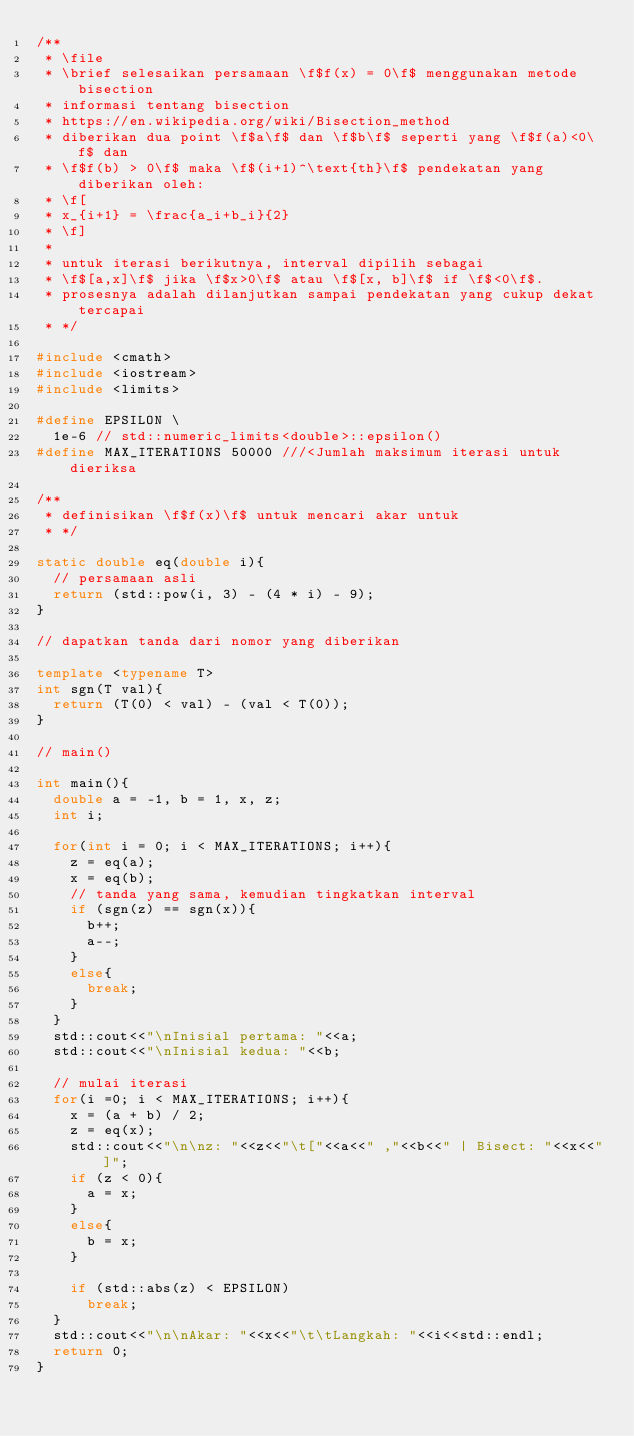Convert code to text. <code><loc_0><loc_0><loc_500><loc_500><_C++_>/**
 * \file
 * \brief selesaikan persamaan \f$f(x) = 0\f$ menggunakan metode bisection
 * informasi tentang bisection
 * https://en.wikipedia.org/wiki/Bisection_method
 * diberikan dua point \f$a\f$ dan \f$b\f$ seperti yang \f$f(a)<0\f$ dan
 * \f$f(b) > 0\f$ maka \f$(i+1)^\text{th}\f$ pendekatan yang diberikan oleh:
 * \f[
 * x_{i+1} = \frac{a_i+b_i}{2}
 * \f]
 *
 * untuk iterasi berikutnya, interval dipilih sebagai
 * \f$[a,x]\f$ jika \f$x>0\f$ atau \f$[x, b]\f$ if \f$<0\f$.
 * prosesnya adalah dilanjutkan sampai pendekatan yang cukup dekat tercapai
 * */

#include <cmath>
#include <iostream>
#include <limits>

#define EPSILON \
  1e-6 // std::numeric_limits<double>::epsilon()
#define MAX_ITERATIONS 50000 ///<Jumlah maksimum iterasi untuk dieriksa

/**
 * definisikan \f$f(x)\f$ untuk mencari akar untuk
 * */

static double eq(double i){
  // persamaan asli
  return (std::pow(i, 3) - (4 * i) - 9);
}

// dapatkan tanda dari nomor yang diberikan

template <typename T>
int sgn(T val){
  return (T(0) < val) - (val < T(0));
}

// main()

int main(){
  double a = -1, b = 1, x, z;
  int i;

  for(int i = 0; i < MAX_ITERATIONS; i++){
    z = eq(a);
    x = eq(b);
    // tanda yang sama, kemudian tingkatkan interval
    if (sgn(z) == sgn(x)){
      b++;
      a--;
    }
    else{
      break;
    }
  }
  std::cout<<"\nInisial pertama: "<<a;
  std::cout<<"\nInisial kedua: "<<b;
  
  // mulai iterasi
  for(i =0; i < MAX_ITERATIONS; i++){
    x = (a + b) / 2;
    z = eq(x);
    std::cout<<"\n\nz: "<<z<<"\t["<<a<<" ,"<<b<<" | Bisect: "<<x<<"]";
    if (z < 0){
      a = x;
    }
    else{
      b = x;
    }
    
    if (std::abs(z) < EPSILON)
      break;
  }
  std::cout<<"\n\nAkar: "<<x<<"\t\tLangkah: "<<i<<std::endl;
  return 0;
}

</code> 